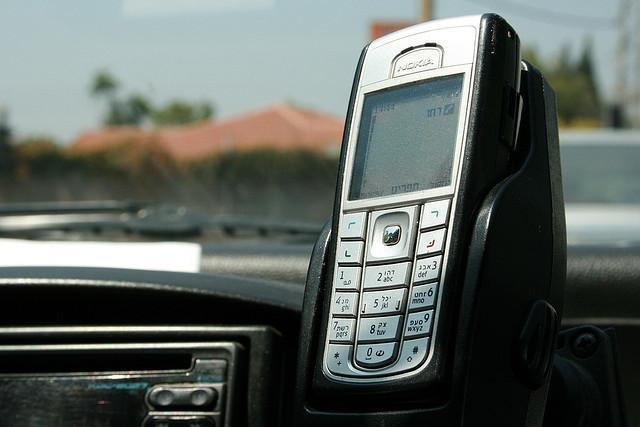How many bags is the man in the photograph carrying?
Give a very brief answer. 0. 